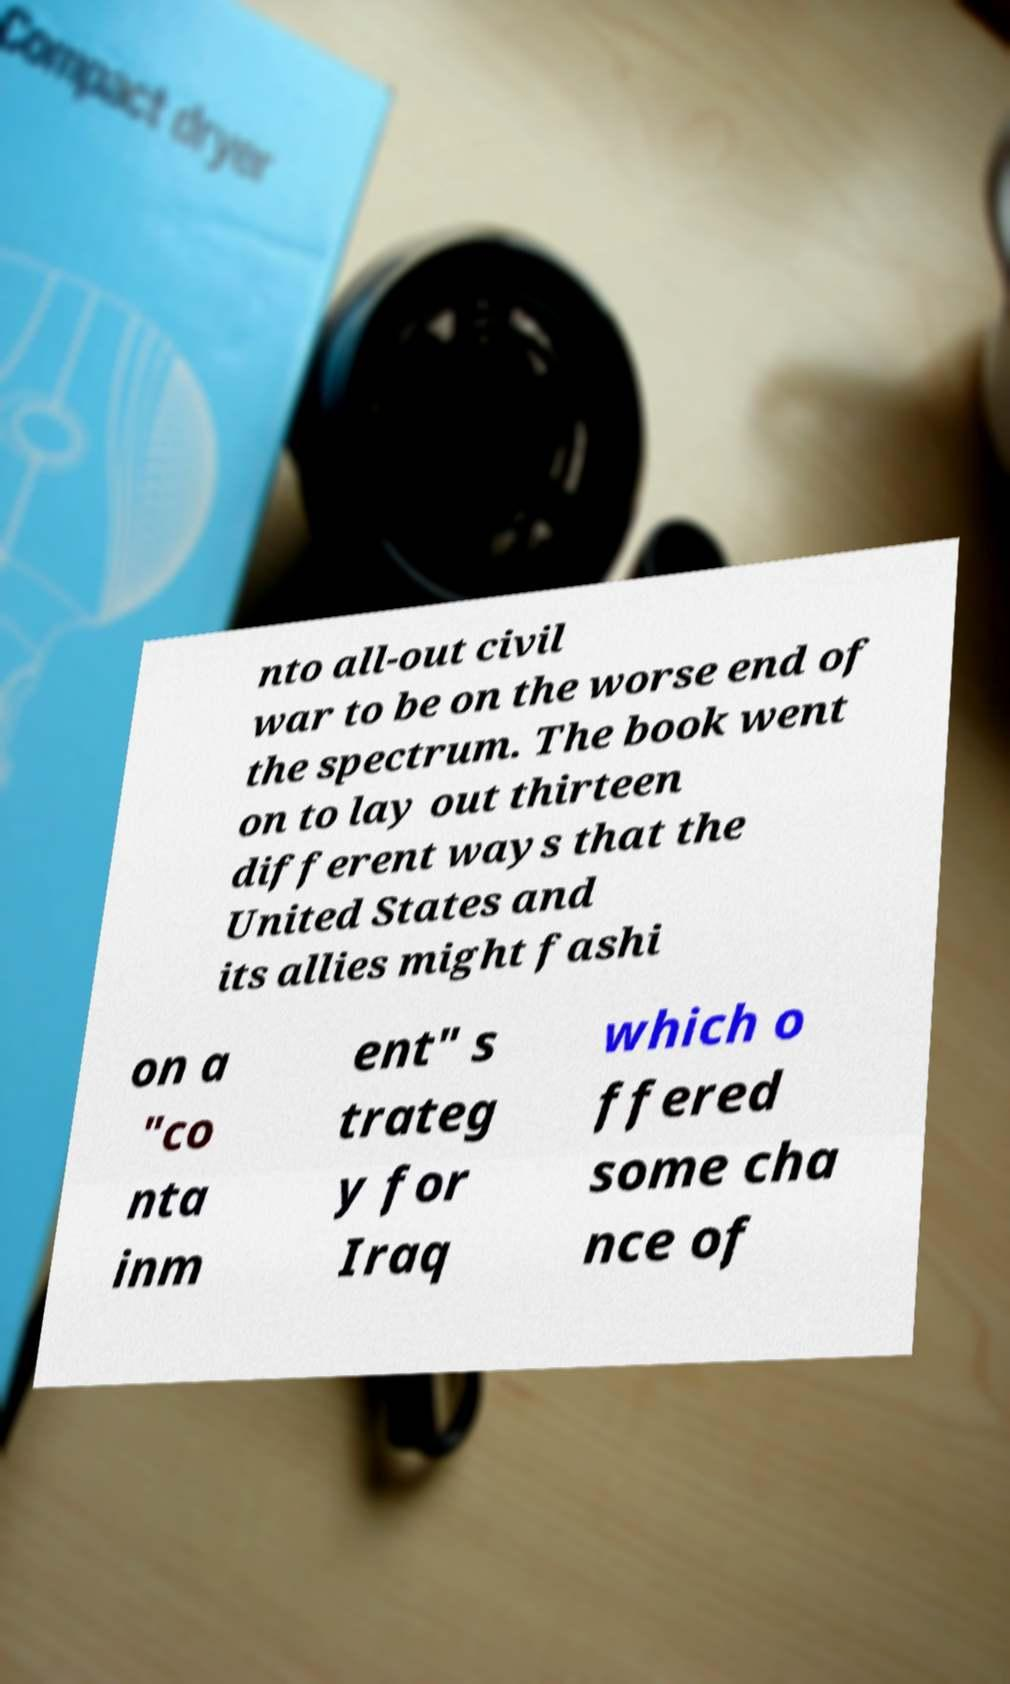Please read and relay the text visible in this image. What does it say? nto all-out civil war to be on the worse end of the spectrum. The book went on to lay out thirteen different ways that the United States and its allies might fashi on a "co nta inm ent" s trateg y for Iraq which o ffered some cha nce of 